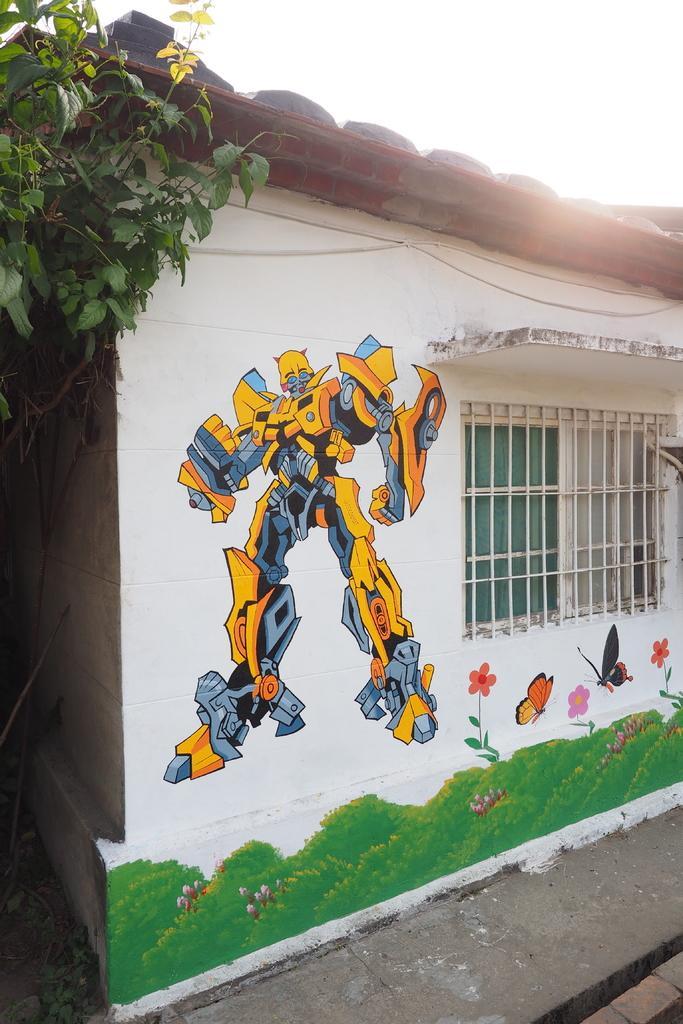Describe this image in one or two sentences. In this image I can see a wall along with the window. on the wall I can see few paintings of robot, flowers, butterflies and grass. On the left side there is a tree. At the top of the image I can see the sky. 